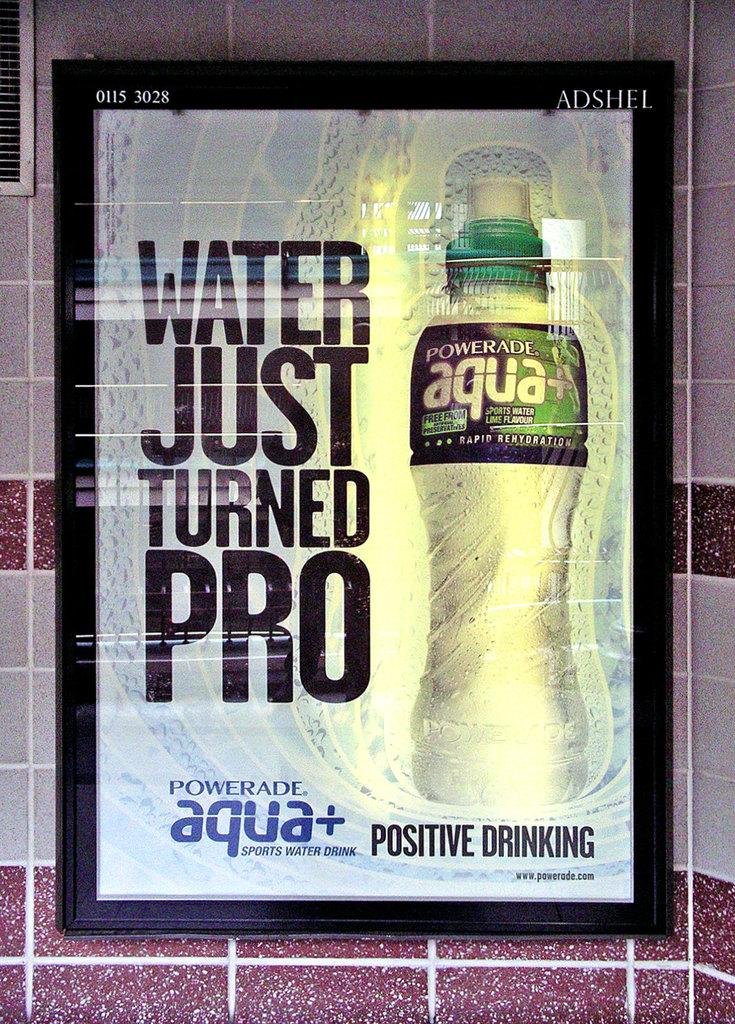<image>
Write a terse but informative summary of the picture. A bottle of powerade aqua has Positive Drinking written underneath it. 